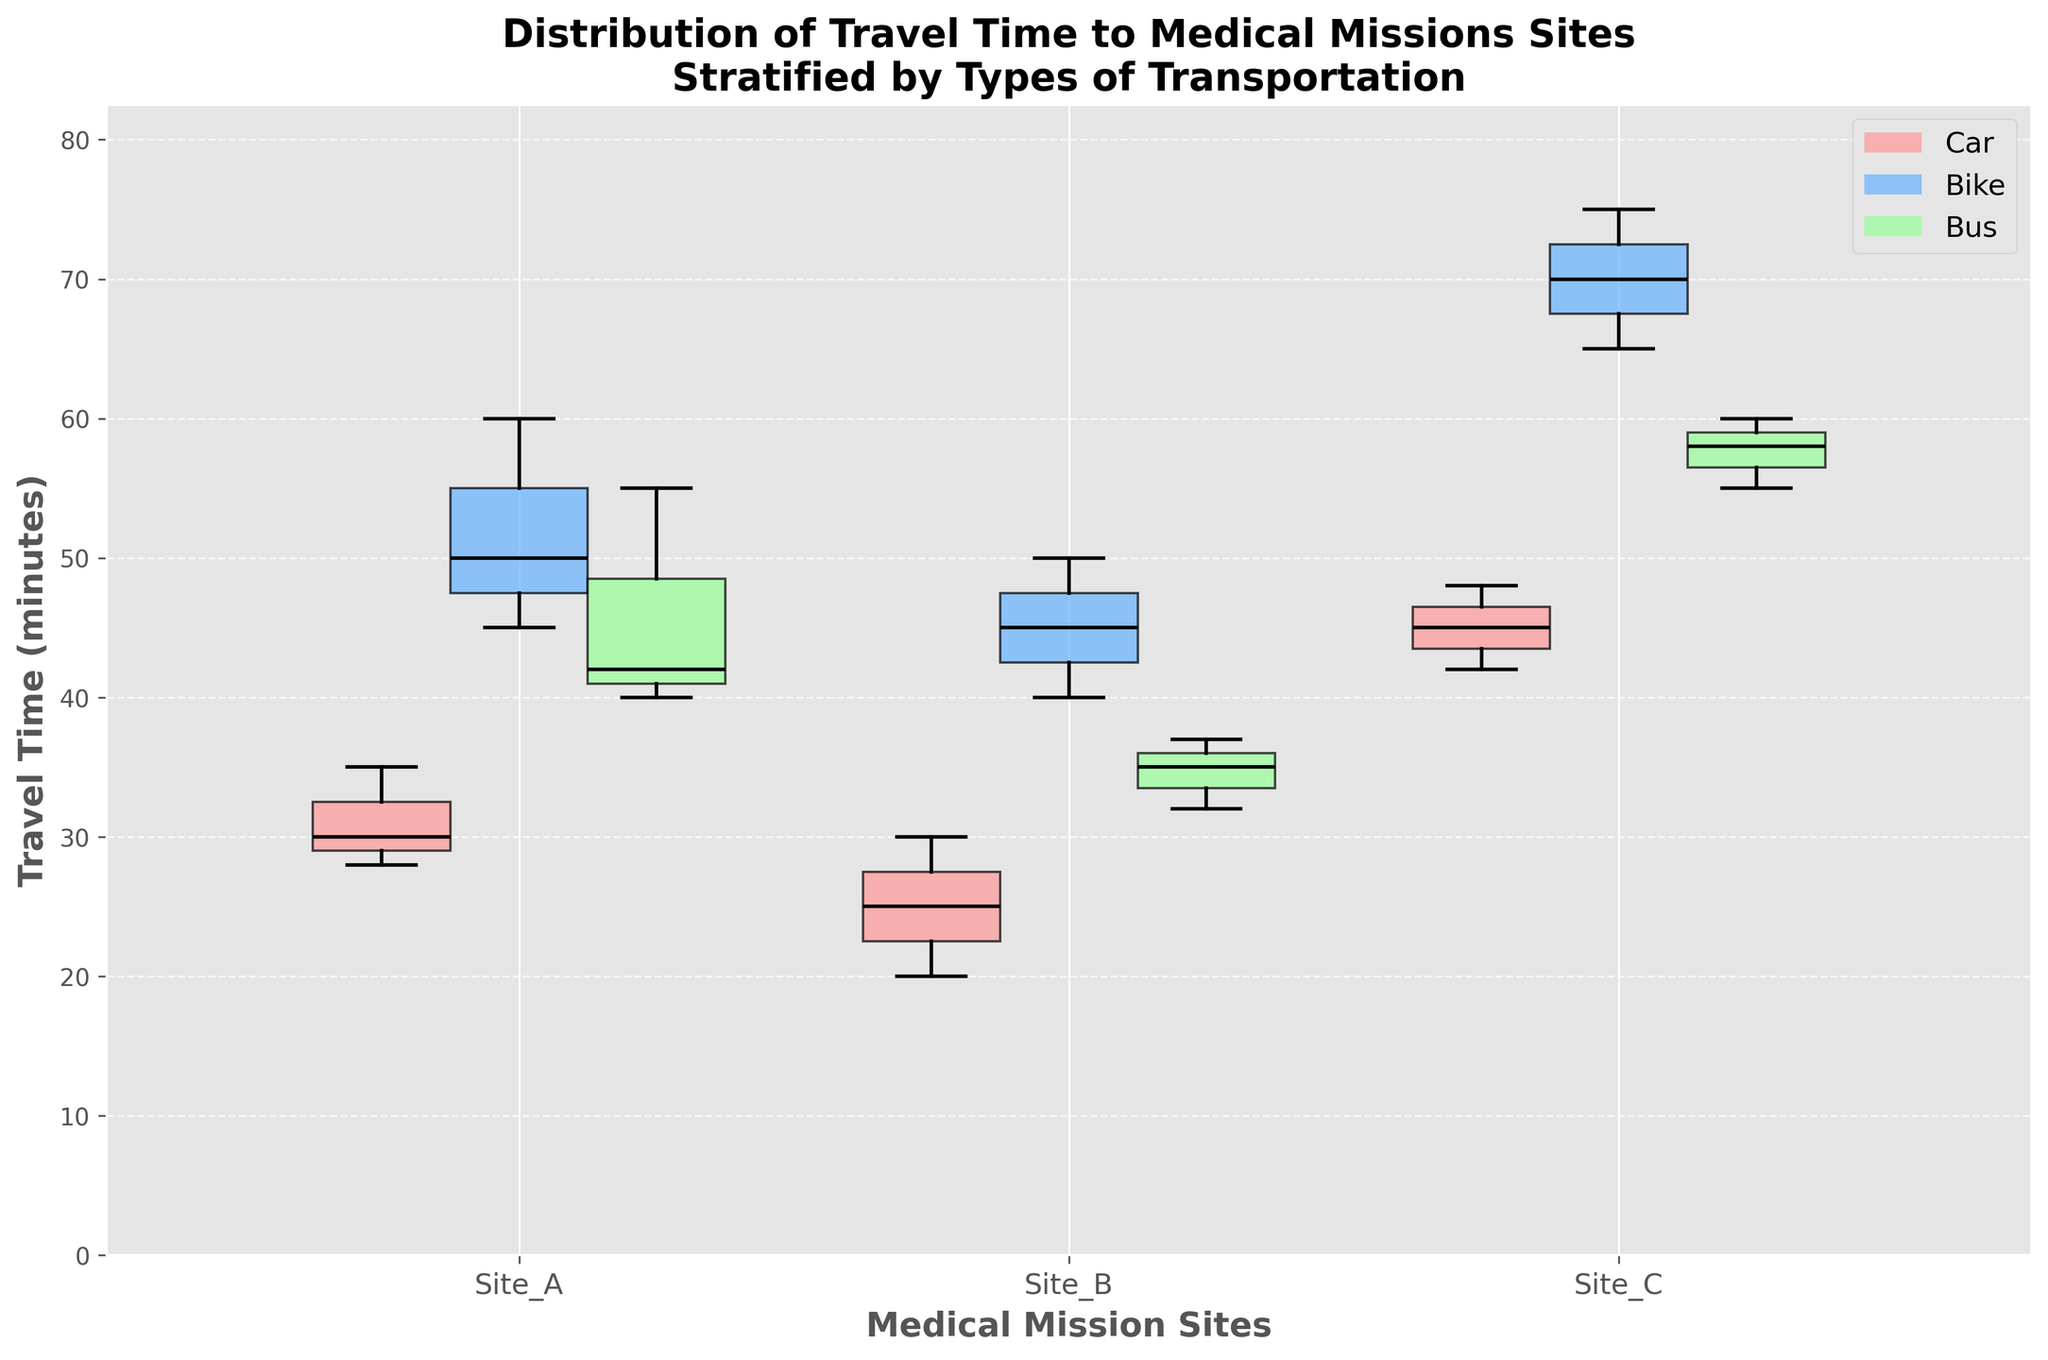What is the title of the plot? The title is displayed at the top of the figure and summarizes the content of the plot, indicating what the plot represents.
Answer: Distribution of Travel Time to Medical Missions Sites Stratified by Types of Transportation What are the types of transportation shown in the plot? The types of transportation are indicated by different colored box plots, as well as being named in the legend at the top-right of the figure.
Answer: Car, Bike, Bus Which transportation type shows the widest range in travel time for Site B? By visually comparing the length of the whiskers and boxes for each transportation type at Site B, we can determine which has the greatest range.
Answer: Bike What is the median travel time for cars to Site A? The median is indicated by the black line inside the box for cars at Site A.
Answer: 30 minutes Which site shows the highest median travel time for buses? By comparing the black median lines within the bus box plots for Sites A, B, and C, we can identify which site has the highest median travel time.
Answer: Site C Compare the interquartile range (IQR) of travel times for bikes between Sites A and C. Which site has a larger IQR? The IQR is the range between the first and third quartiles (the edges of the box). By comparing the box heights for bikes at Sites A and C, we can see which one is larger.
Answer: Site C How does the distribution of travel times for cars to Site C compare to Site A? By comparing the entire box plot of cars between Site C and Site A, look at the spread, median, and range differences.
Answer: Site C has a higher median and a wider range Which site has the smallest range of travel times for buses? The range is the difference between the maximum and minimum values represented by the whiskers. Compare the whisker lengths for buses across Sites A, B, and C.
Answer: Site B How does the variability in travel times for bikes at Site B compare to Site A? Variability can be assessed by looking at the spread of the box plots and the range, including the whiskers, for bikes at both sites.
Answer: Site B has less variability compared to Site A What insights can you derive about the efficiency of traveling by car to medical mission sites? By analyzing the median, range, and variability of the box plots for cars across Sites A, B, and C, we can infer the consistency and reliability of travel times by car.
Answer: Efficient with lower variability and moderate range across sites 